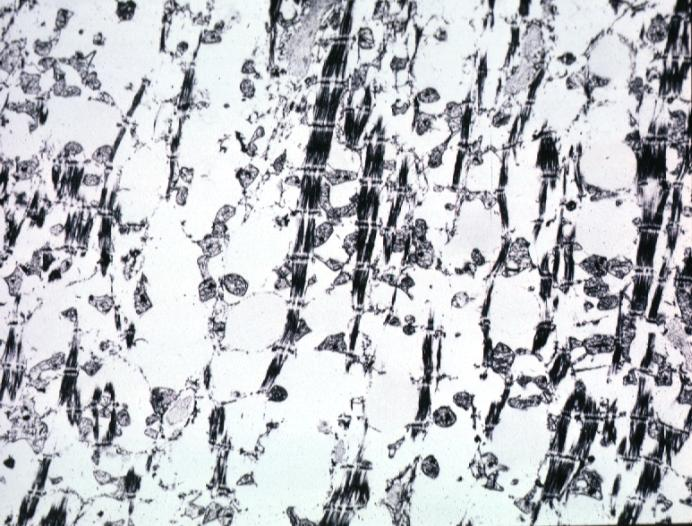what contains not lipid?
Answer the question using a single word or phrase. Formalin fixed and too good but does show lesion of myocytolysis 